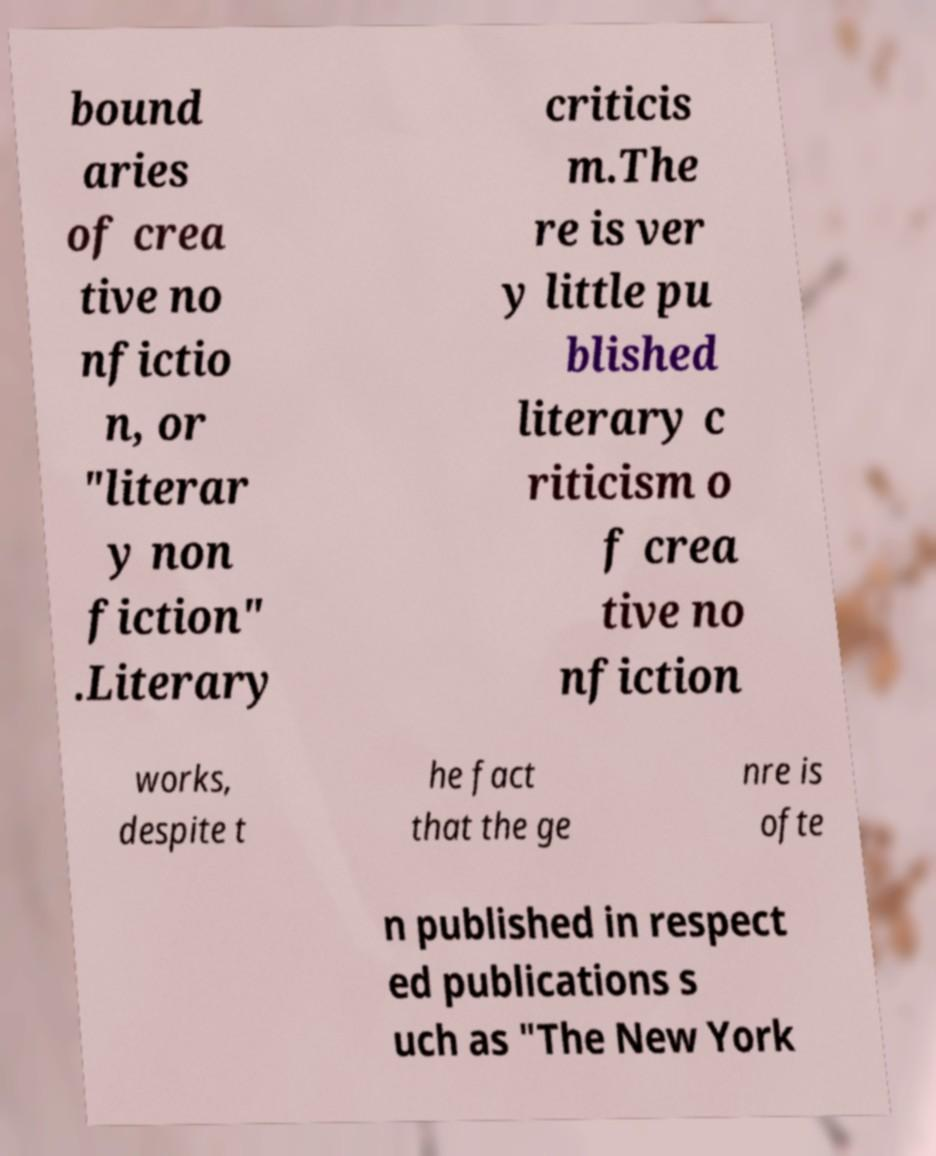There's text embedded in this image that I need extracted. Can you transcribe it verbatim? bound aries of crea tive no nfictio n, or "literar y non fiction" .Literary criticis m.The re is ver y little pu blished literary c riticism o f crea tive no nfiction works, despite t he fact that the ge nre is ofte n published in respect ed publications s uch as "The New York 